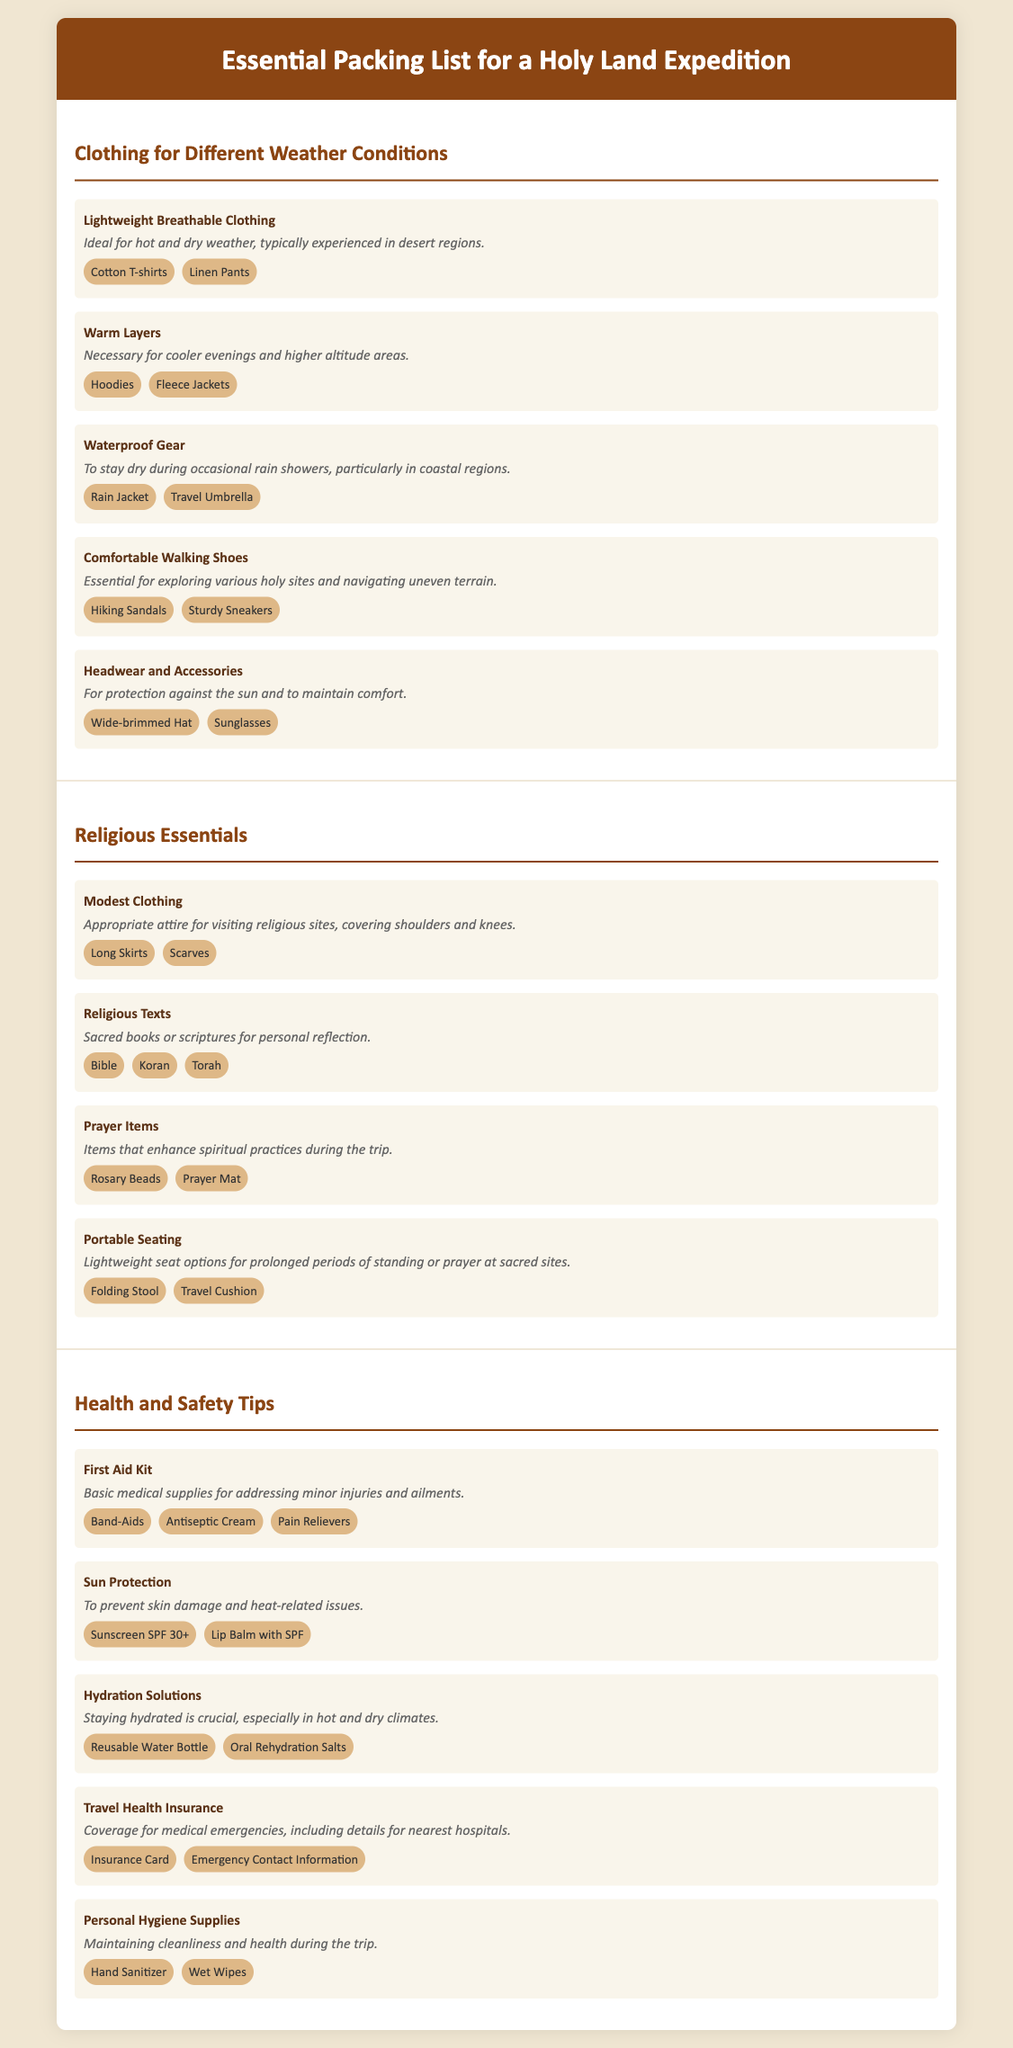What kind of clothing is suggested for hot weather? The document specifies "Lightweight Breathable Clothing" as ideal for hot and dry weather.
Answer: Lightweight Breathable Clothing What is a recommended item for cooler evenings? The document advises bringing "Warm Layers" necessary for cooler evenings and higher altitude areas.
Answer: Warm Layers What should you bring for sun protection? "Sun Protection" is mentioned, with recommended items like sunscreen and lip balm.
Answer: Sun Protection Which item is suggested for visiting religious sites? The document lists "Modest Clothing" as appropriate attire for visiting religious sites.
Answer: Modest Clothing What hydration solution is recommended? The document mentions "Hydration Solutions," specifically a reusable water bottle and oral rehydration salts for hydration.
Answer: Hydration Solutions How many items are listed under Health and Safety Tips? There are five items specifically listed under the Health and Safety Tips section.
Answer: Five items What is an example of portable seating mentioned? The document suggests "Folding Stool" as an example of portable seating.
Answer: Folding Stool Which type of footwear is essential for exploring holy sites? The document emphasizes the need for "Comfortable Walking Shoes" for exploring various holy sites.
Answer: Comfortable Walking Shoes What does the document recommend carrying for first aid? A "First Aid Kit" is recommended for addressing minor injuries and ailments.
Answer: First Aid Kit 